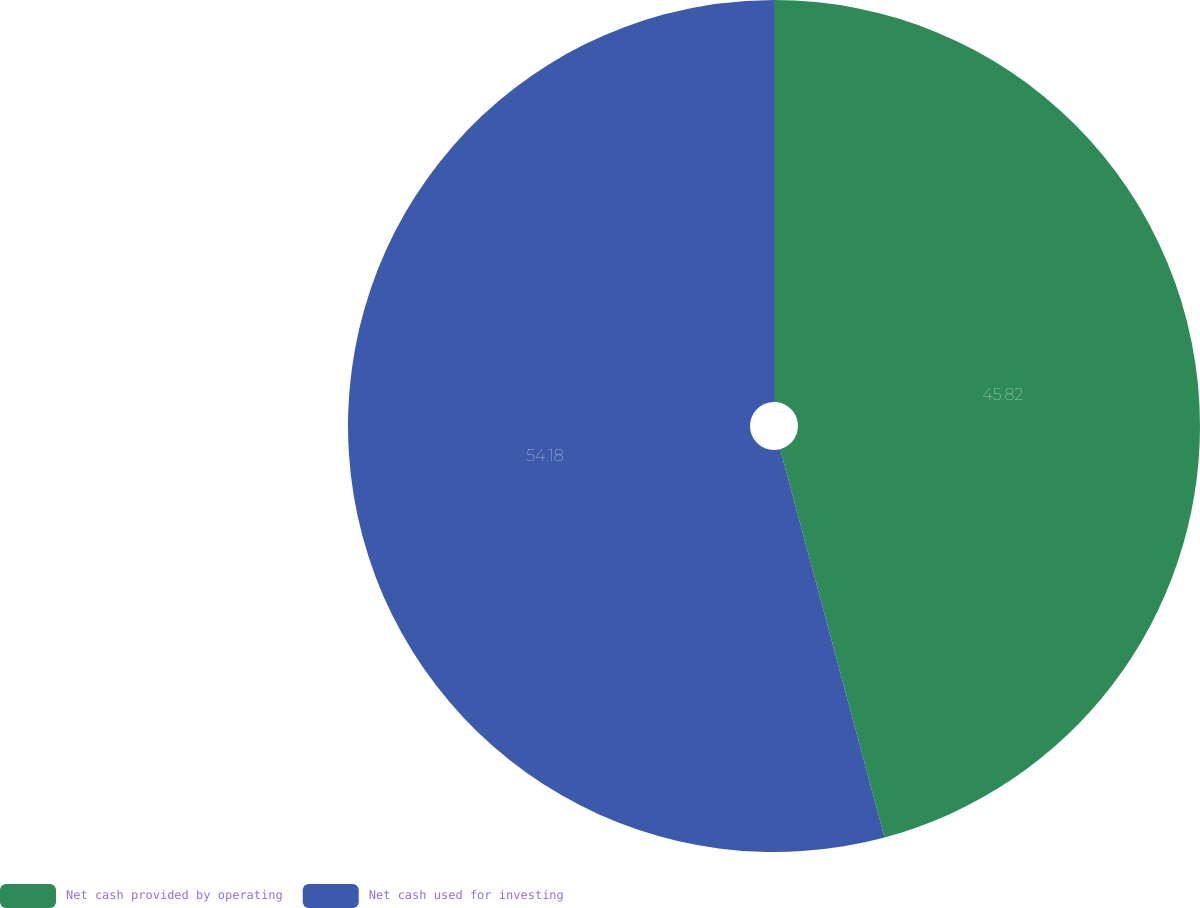Convert chart. <chart><loc_0><loc_0><loc_500><loc_500><pie_chart><fcel>Net cash provided by operating<fcel>Net cash used for investing<nl><fcel>45.82%<fcel>54.18%<nl></chart> 